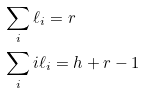<formula> <loc_0><loc_0><loc_500><loc_500>& \sum _ { i } \ell _ { i } = r & & \\ & \sum _ { i } i \ell _ { i } = h + r - 1 & &</formula> 